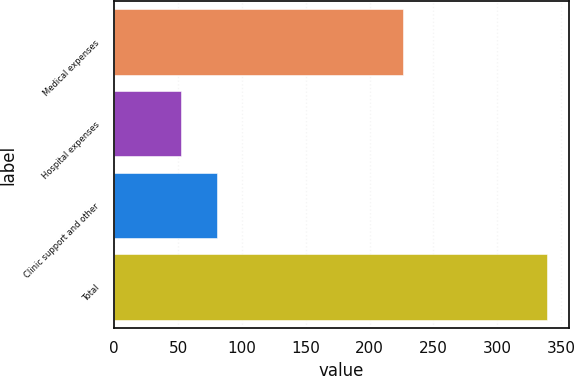Convert chart to OTSL. <chart><loc_0><loc_0><loc_500><loc_500><bar_chart><fcel>Medical expenses<fcel>Hospital expenses<fcel>Clinic support and other<fcel>Total<nl><fcel>226<fcel>52<fcel>80.7<fcel>339<nl></chart> 